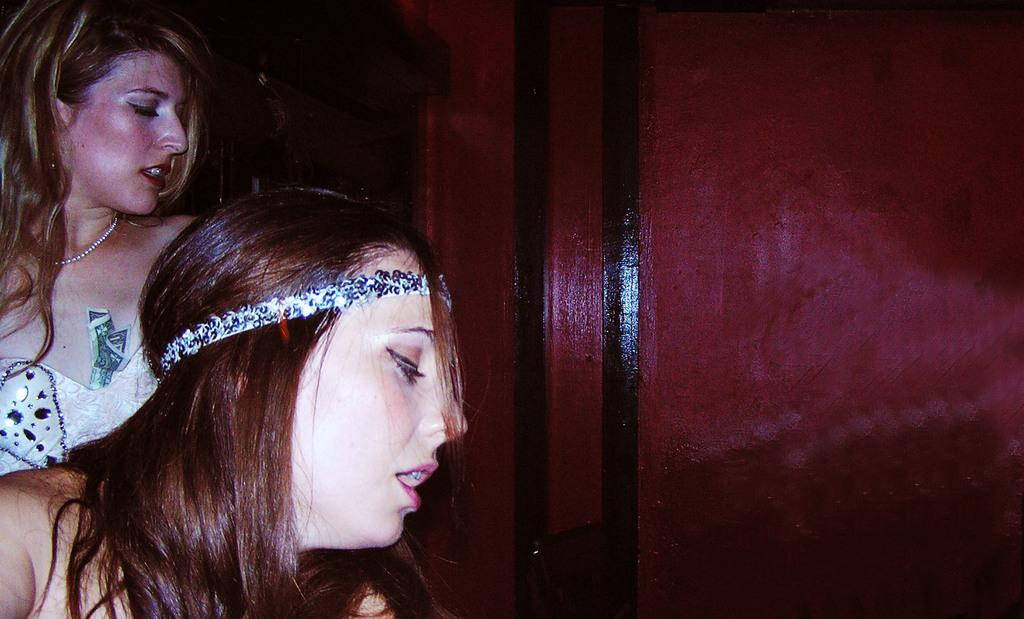How many people are in the image? There are two women in the image. What are the women doing in the image? The women are on a path. What can be seen on the right side of the women? There is a wall on the right side of the women. What type of digestion issues are the women discussing in the image? There is no indication in the image that the women are discussing digestion issues or any other specific topic. 